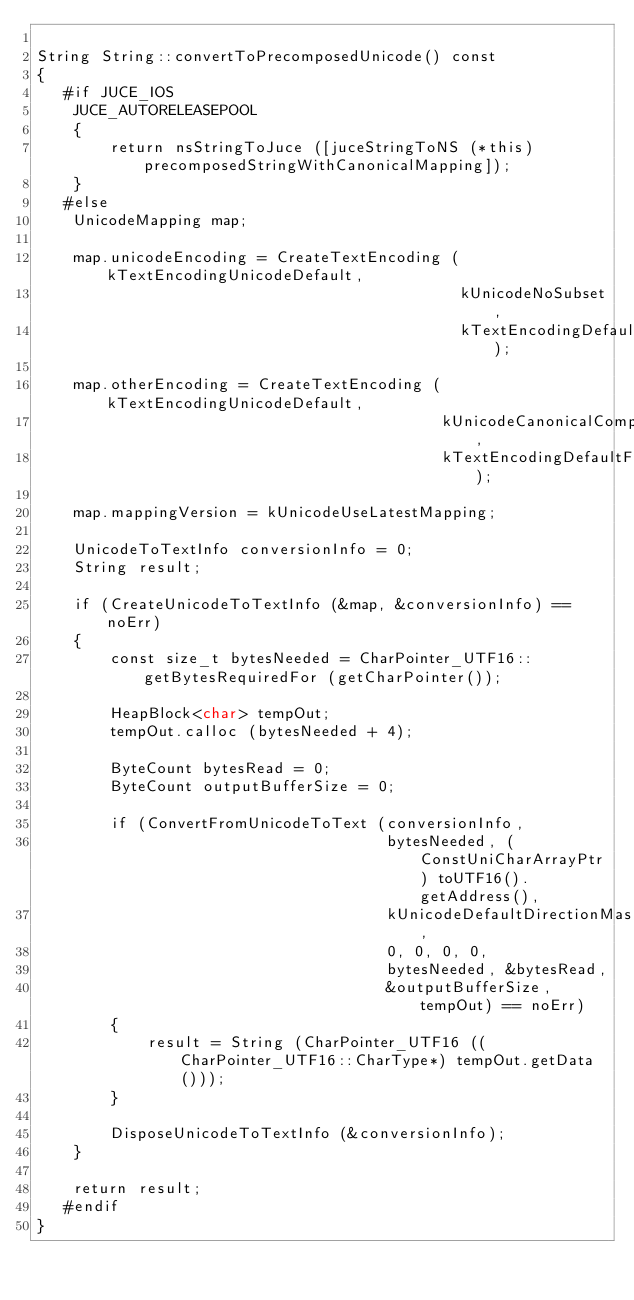<code> <loc_0><loc_0><loc_500><loc_500><_ObjectiveC_>
String String::convertToPrecomposedUnicode() const
{
   #if JUCE_IOS
    JUCE_AUTORELEASEPOOL
    {
        return nsStringToJuce ([juceStringToNS (*this) precomposedStringWithCanonicalMapping]);
    }
   #else
    UnicodeMapping map;

    map.unicodeEncoding = CreateTextEncoding (kTextEncodingUnicodeDefault,
                                              kUnicodeNoSubset,
                                              kTextEncodingDefaultFormat);

    map.otherEncoding = CreateTextEncoding (kTextEncodingUnicodeDefault,
                                            kUnicodeCanonicalCompVariant,
                                            kTextEncodingDefaultFormat);

    map.mappingVersion = kUnicodeUseLatestMapping;

    UnicodeToTextInfo conversionInfo = 0;
    String result;

    if (CreateUnicodeToTextInfo (&map, &conversionInfo) == noErr)
    {
        const size_t bytesNeeded = CharPointer_UTF16::getBytesRequiredFor (getCharPointer());

        HeapBlock<char> tempOut;
        tempOut.calloc (bytesNeeded + 4);

        ByteCount bytesRead = 0;
        ByteCount outputBufferSize = 0;

        if (ConvertFromUnicodeToText (conversionInfo,
                                      bytesNeeded, (ConstUniCharArrayPtr) toUTF16().getAddress(),
                                      kUnicodeDefaultDirectionMask,
                                      0, 0, 0, 0,
                                      bytesNeeded, &bytesRead,
                                      &outputBufferSize, tempOut) == noErr)
        {
            result = String (CharPointer_UTF16 ((CharPointer_UTF16::CharType*) tempOut.getData()));
        }

        DisposeUnicodeToTextInfo (&conversionInfo);
    }

    return result;
   #endif
}
</code> 